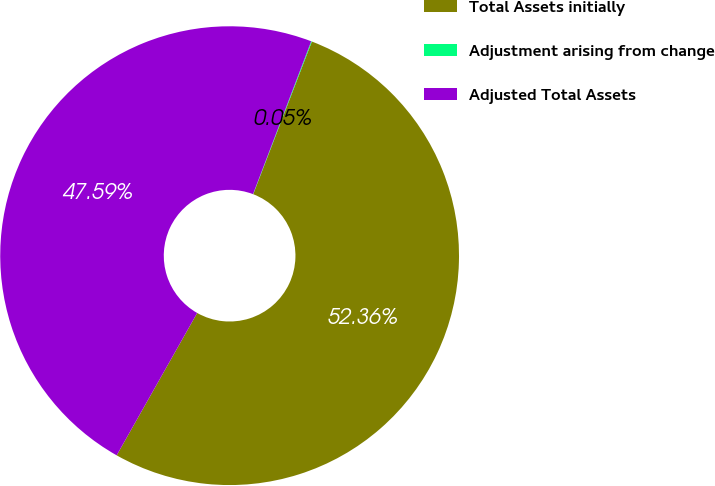<chart> <loc_0><loc_0><loc_500><loc_500><pie_chart><fcel>Total Assets initially<fcel>Adjustment arising from change<fcel>Adjusted Total Assets<nl><fcel>52.35%<fcel>0.05%<fcel>47.59%<nl></chart> 